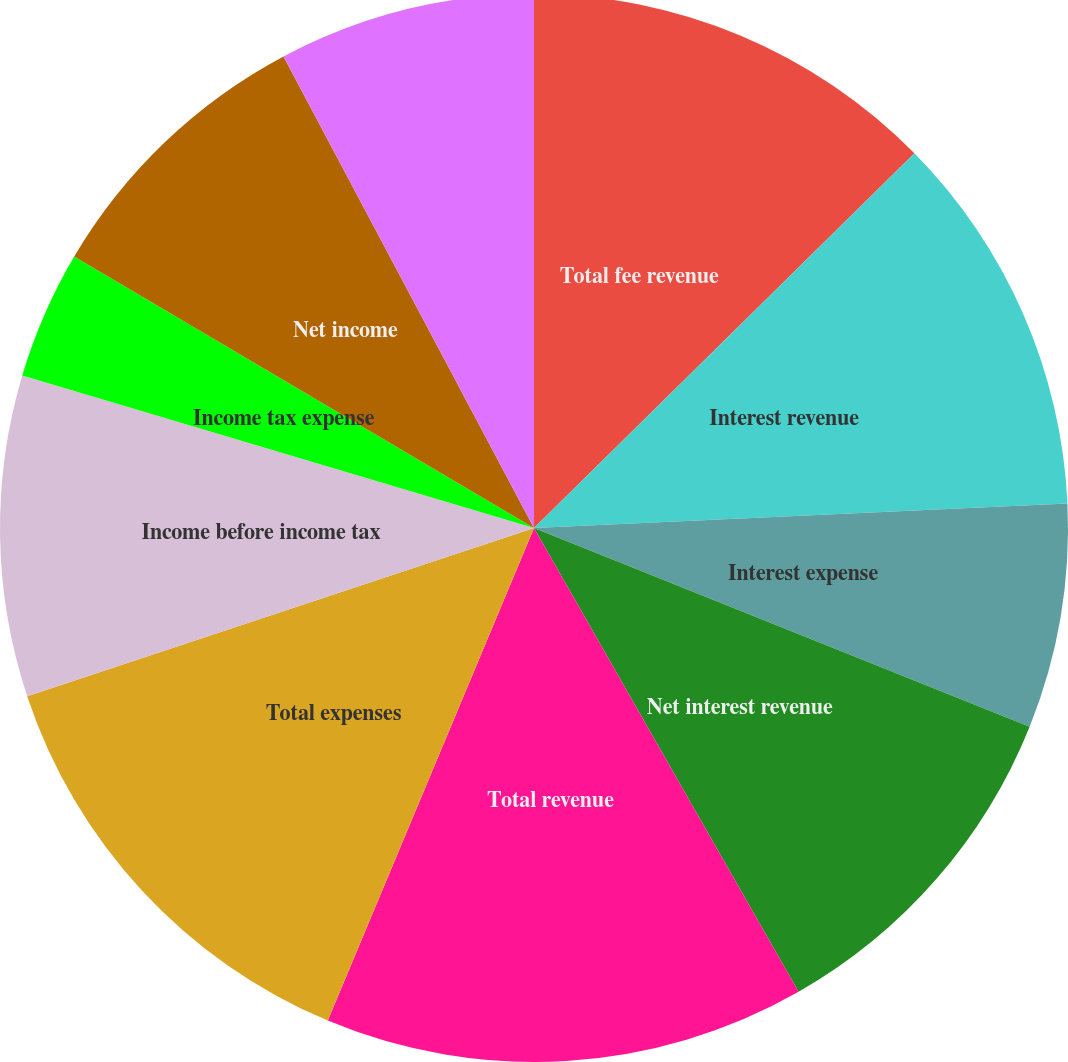Convert chart to OTSL. <chart><loc_0><loc_0><loc_500><loc_500><pie_chart><fcel>Total fee revenue<fcel>Interest revenue<fcel>Interest expense<fcel>Net interest revenue<fcel>Total revenue<fcel>Total expenses<fcel>Income before income tax<fcel>Income tax expense<fcel>Net income<fcel>Net income available to common<nl><fcel>12.62%<fcel>11.65%<fcel>6.8%<fcel>10.68%<fcel>14.56%<fcel>13.59%<fcel>9.71%<fcel>3.88%<fcel>8.74%<fcel>7.77%<nl></chart> 